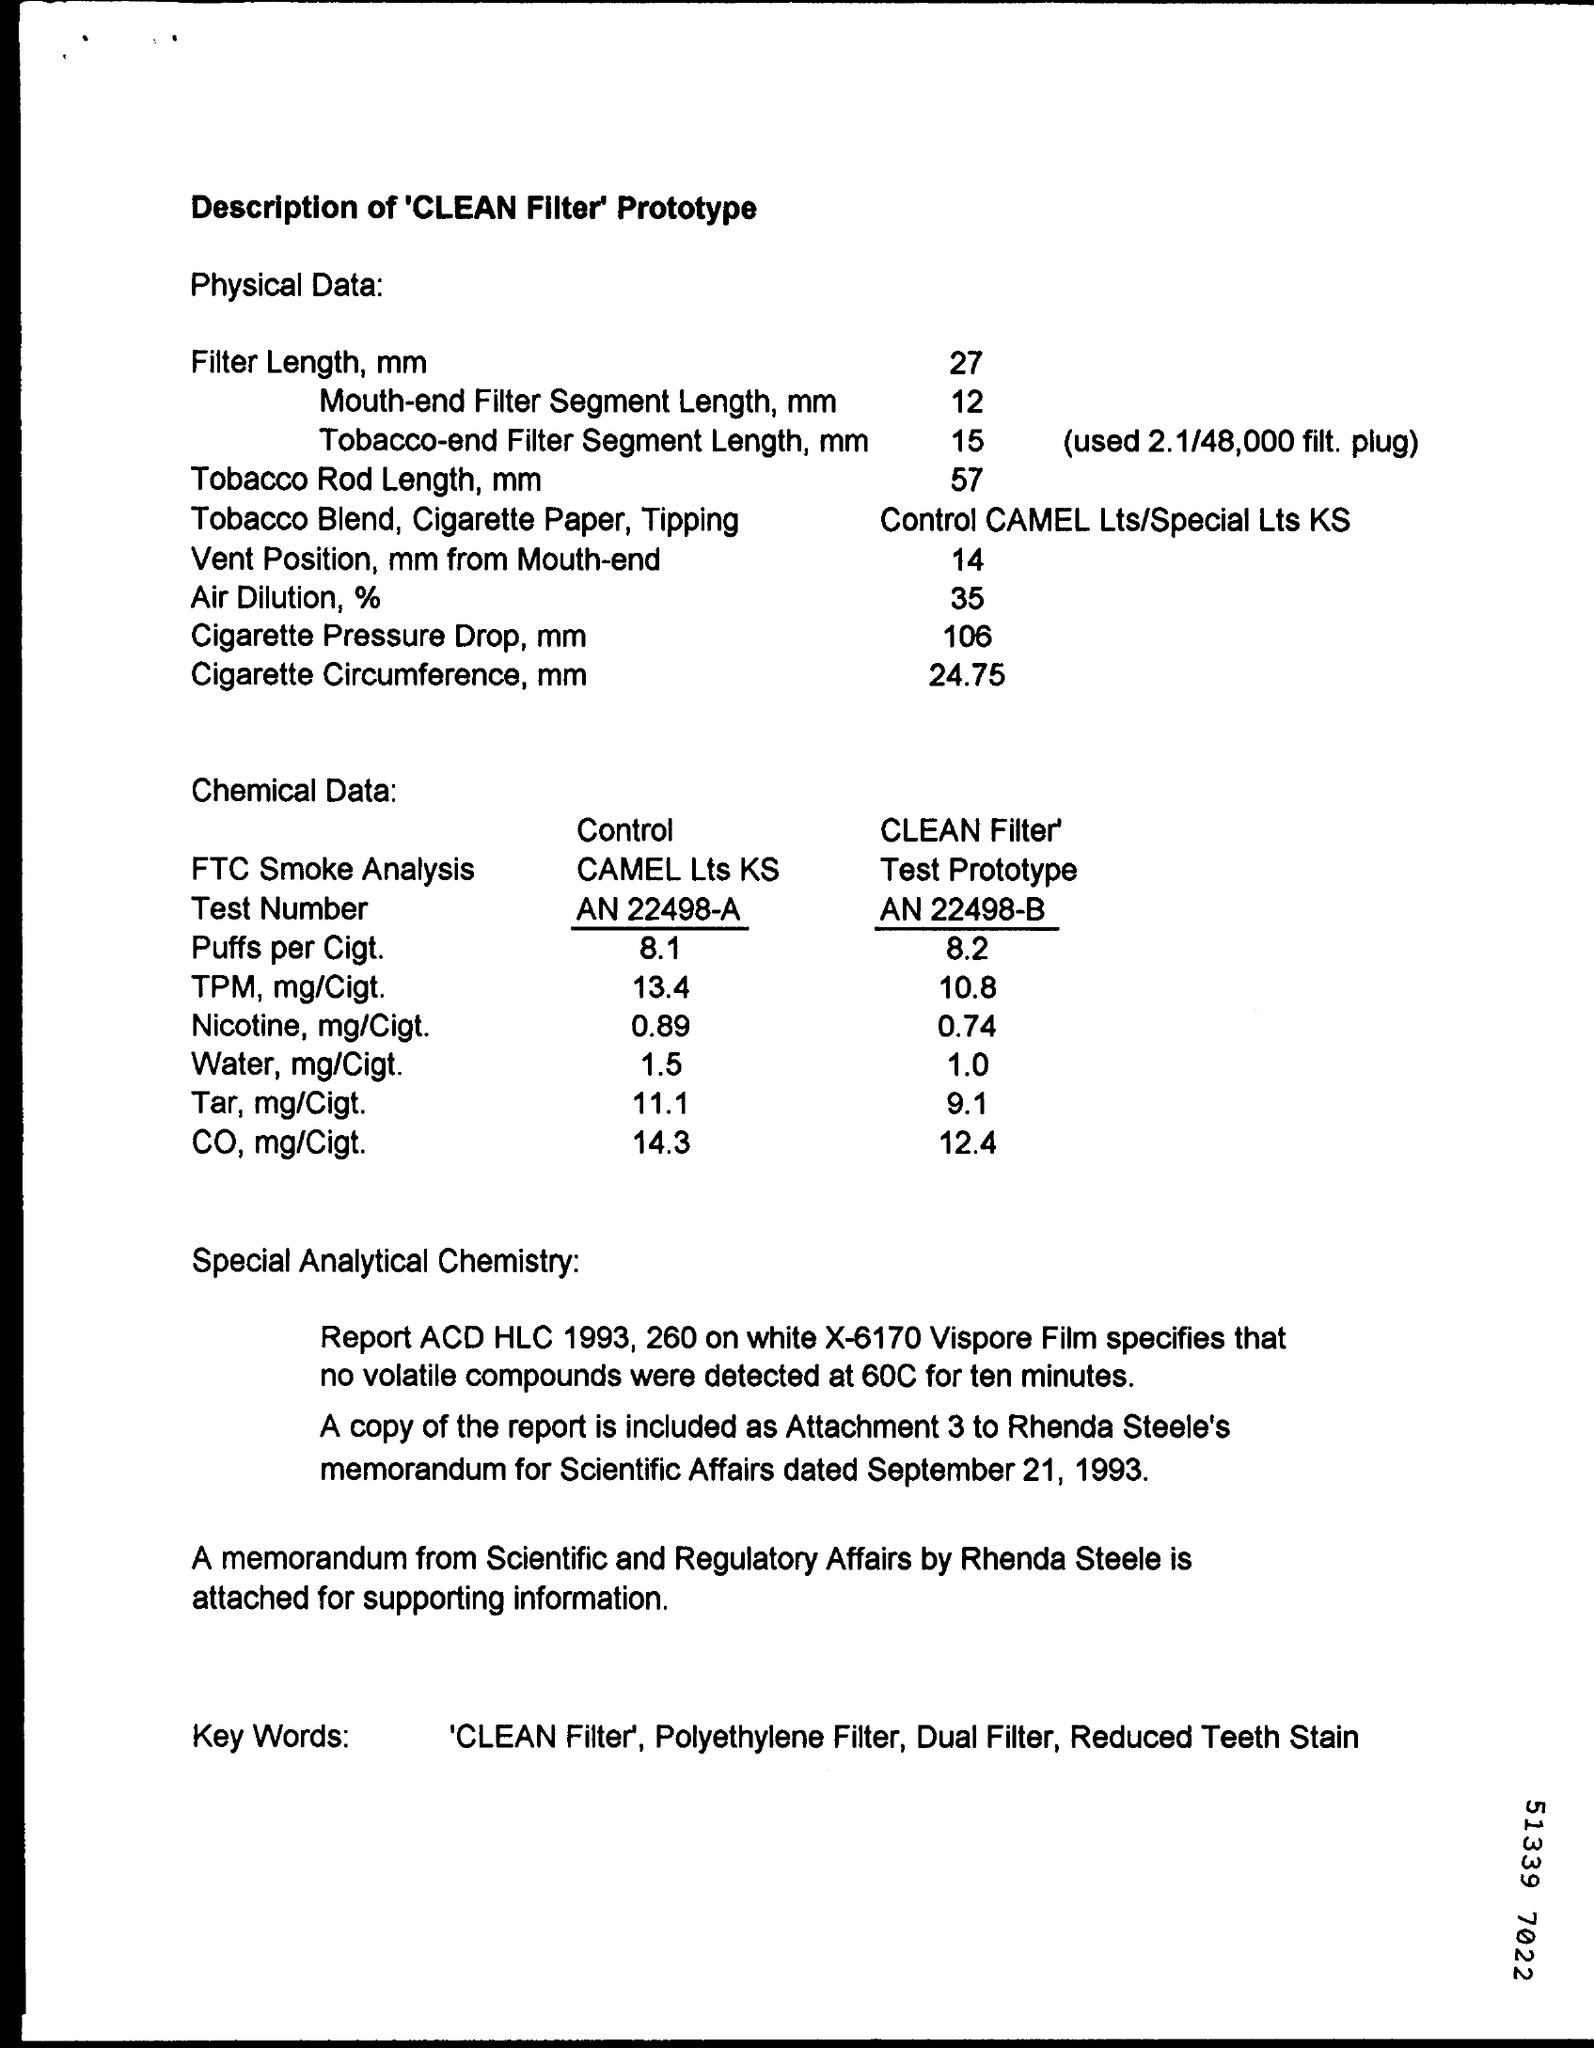List a handful of essential elements in this visual. What is the Test Number of Control CAMEL Lts Ks? AN 22498-A..." is a question that asks for information about a specific test related to Control CAMEL Lts Ks. This document is a description of the 'CLEAN Filter' prototype, which is a tool designed to improve the cleaning process in the field of microscopy. The clean filter test prototype contains 12.4 milligrams of CO per cigarette. The filter length in mm is 27. The cigarette circumference in mm is 24.75. 